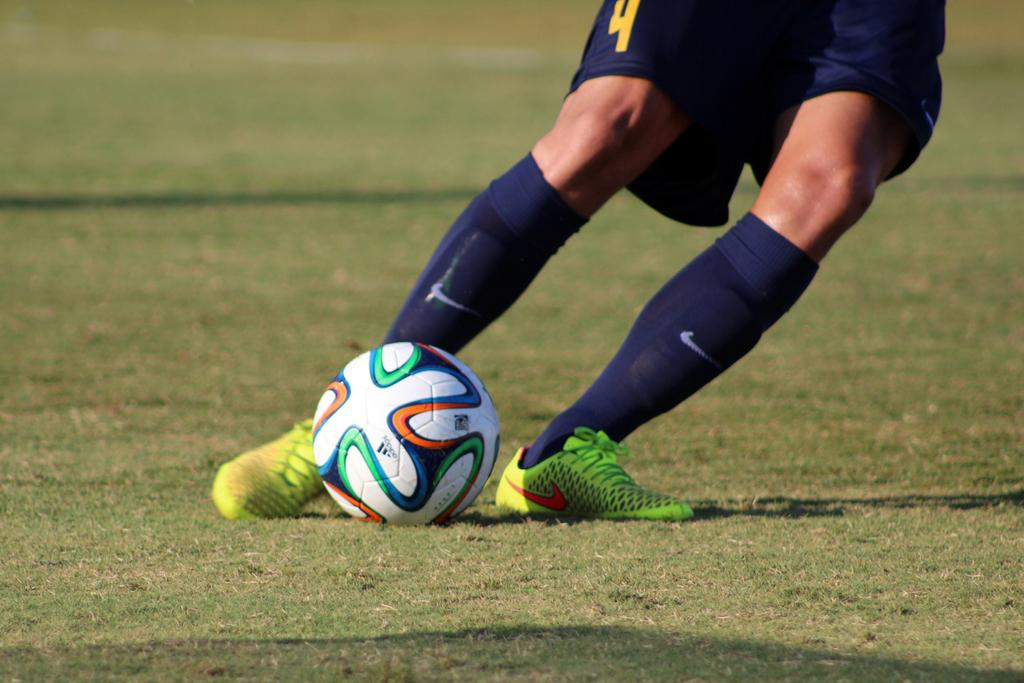Provide a one-sentence caption for the provided image. Player number 4 kicks the soccer ball while wearing Nike socks. 